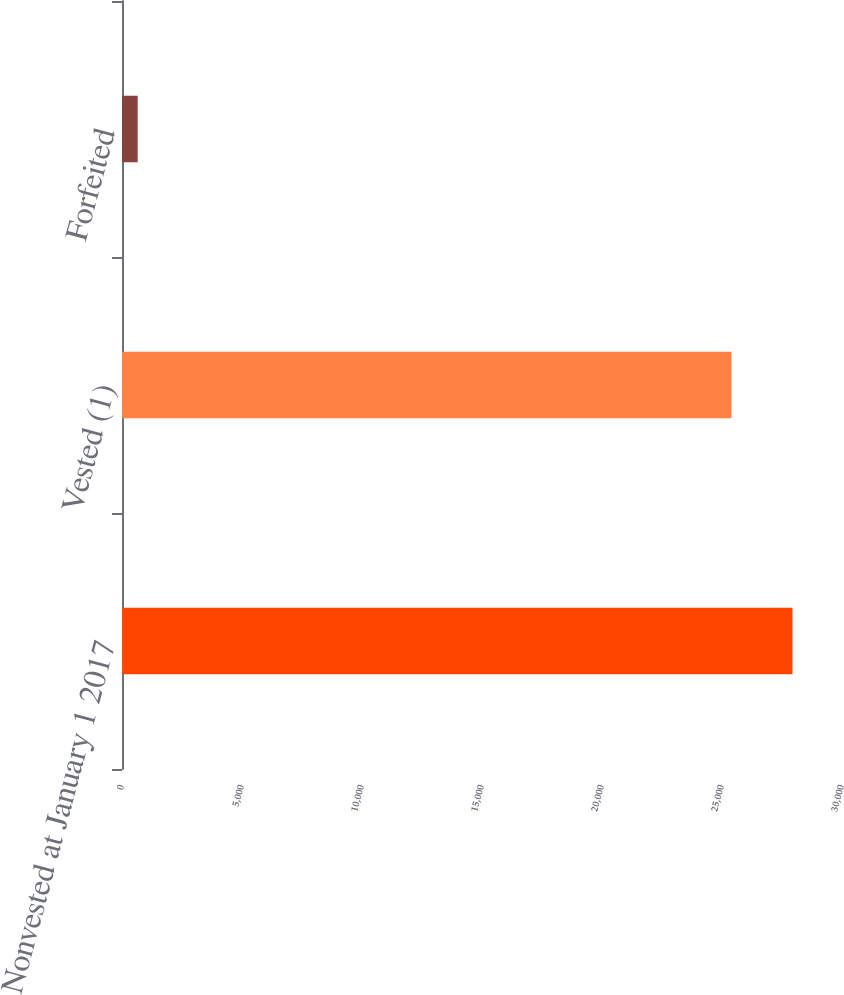<chart> <loc_0><loc_0><loc_500><loc_500><bar_chart><fcel>Nonvested at January 1 2017<fcel>Vested (1)<fcel>Forfeited<nl><fcel>27937.8<fcel>25398<fcel>654<nl></chart> 